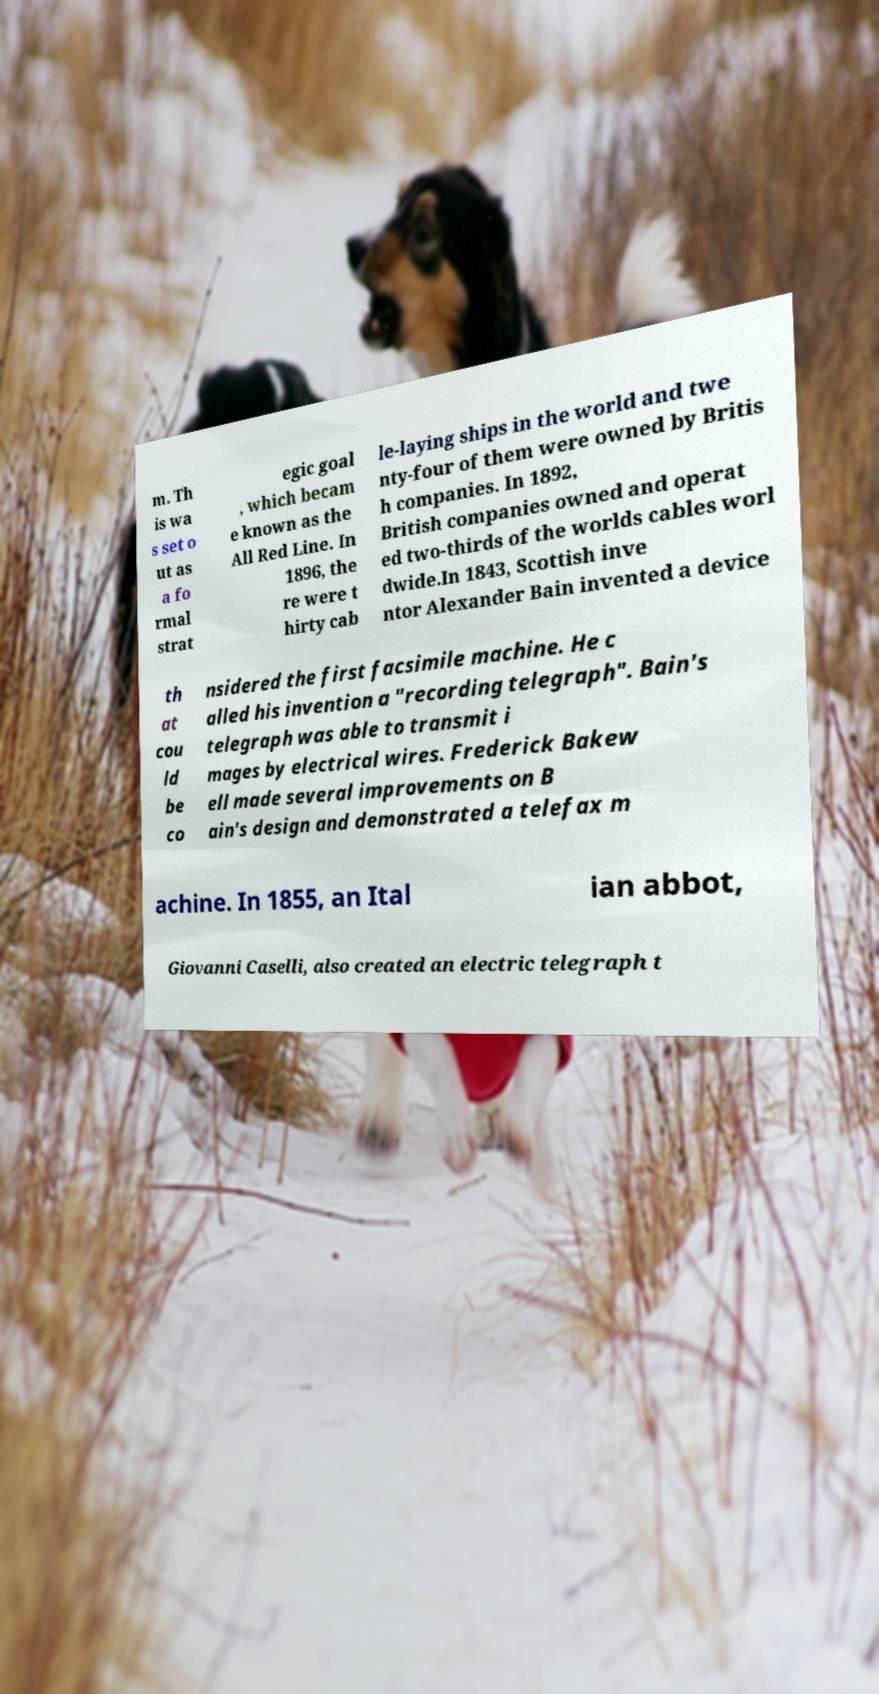Can you read and provide the text displayed in the image?This photo seems to have some interesting text. Can you extract and type it out for me? m. Th is wa s set o ut as a fo rmal strat egic goal , which becam e known as the All Red Line. In 1896, the re were t hirty cab le-laying ships in the world and twe nty-four of them were owned by Britis h companies. In 1892, British companies owned and operat ed two-thirds of the worlds cables worl dwide.In 1843, Scottish inve ntor Alexander Bain invented a device th at cou ld be co nsidered the first facsimile machine. He c alled his invention a "recording telegraph". Bain's telegraph was able to transmit i mages by electrical wires. Frederick Bakew ell made several improvements on B ain's design and demonstrated a telefax m achine. In 1855, an Ital ian abbot, Giovanni Caselli, also created an electric telegraph t 